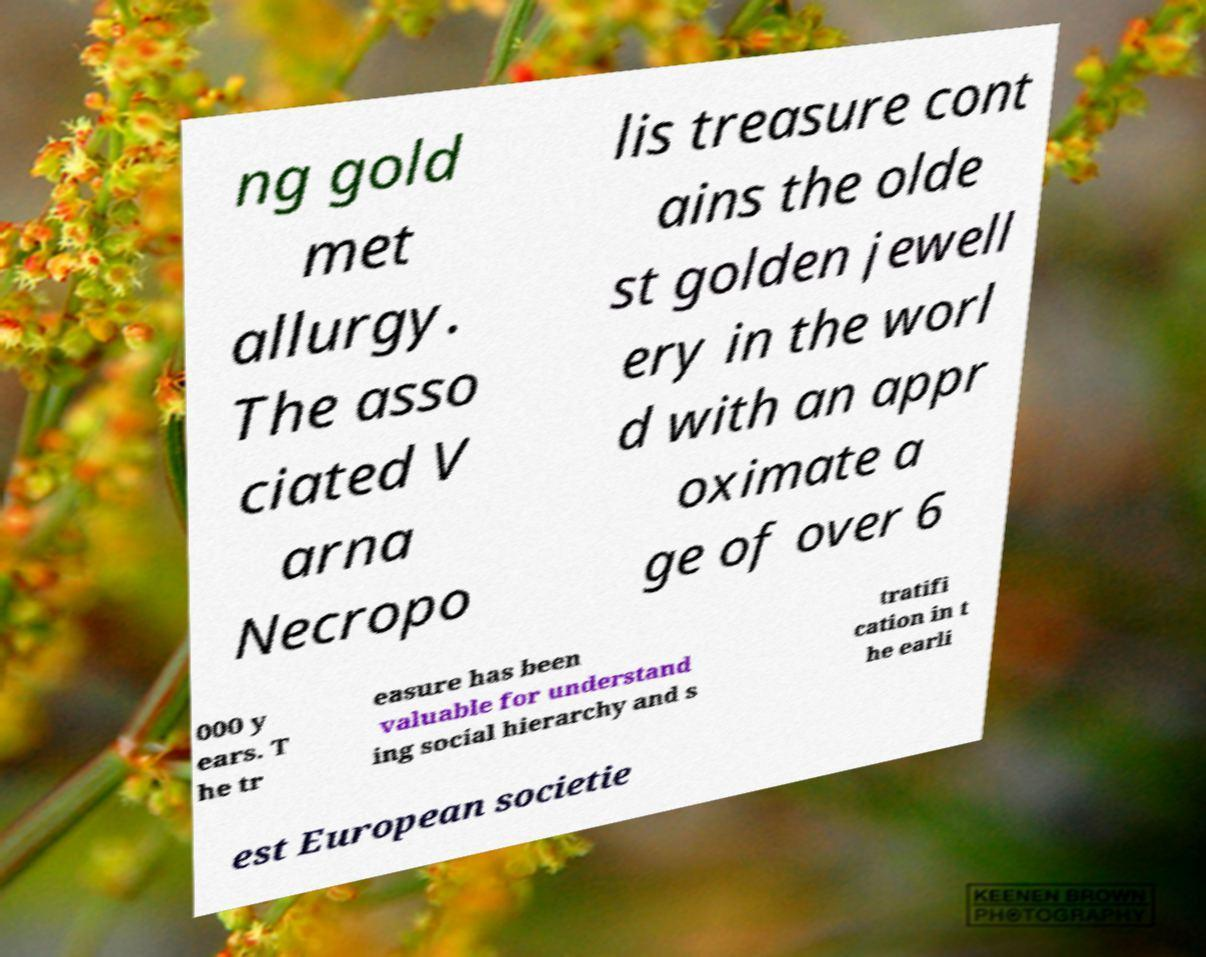For documentation purposes, I need the text within this image transcribed. Could you provide that? ng gold met allurgy. The asso ciated V arna Necropo lis treasure cont ains the olde st golden jewell ery in the worl d with an appr oximate a ge of over 6 000 y ears. T he tr easure has been valuable for understand ing social hierarchy and s tratifi cation in t he earli est European societie 